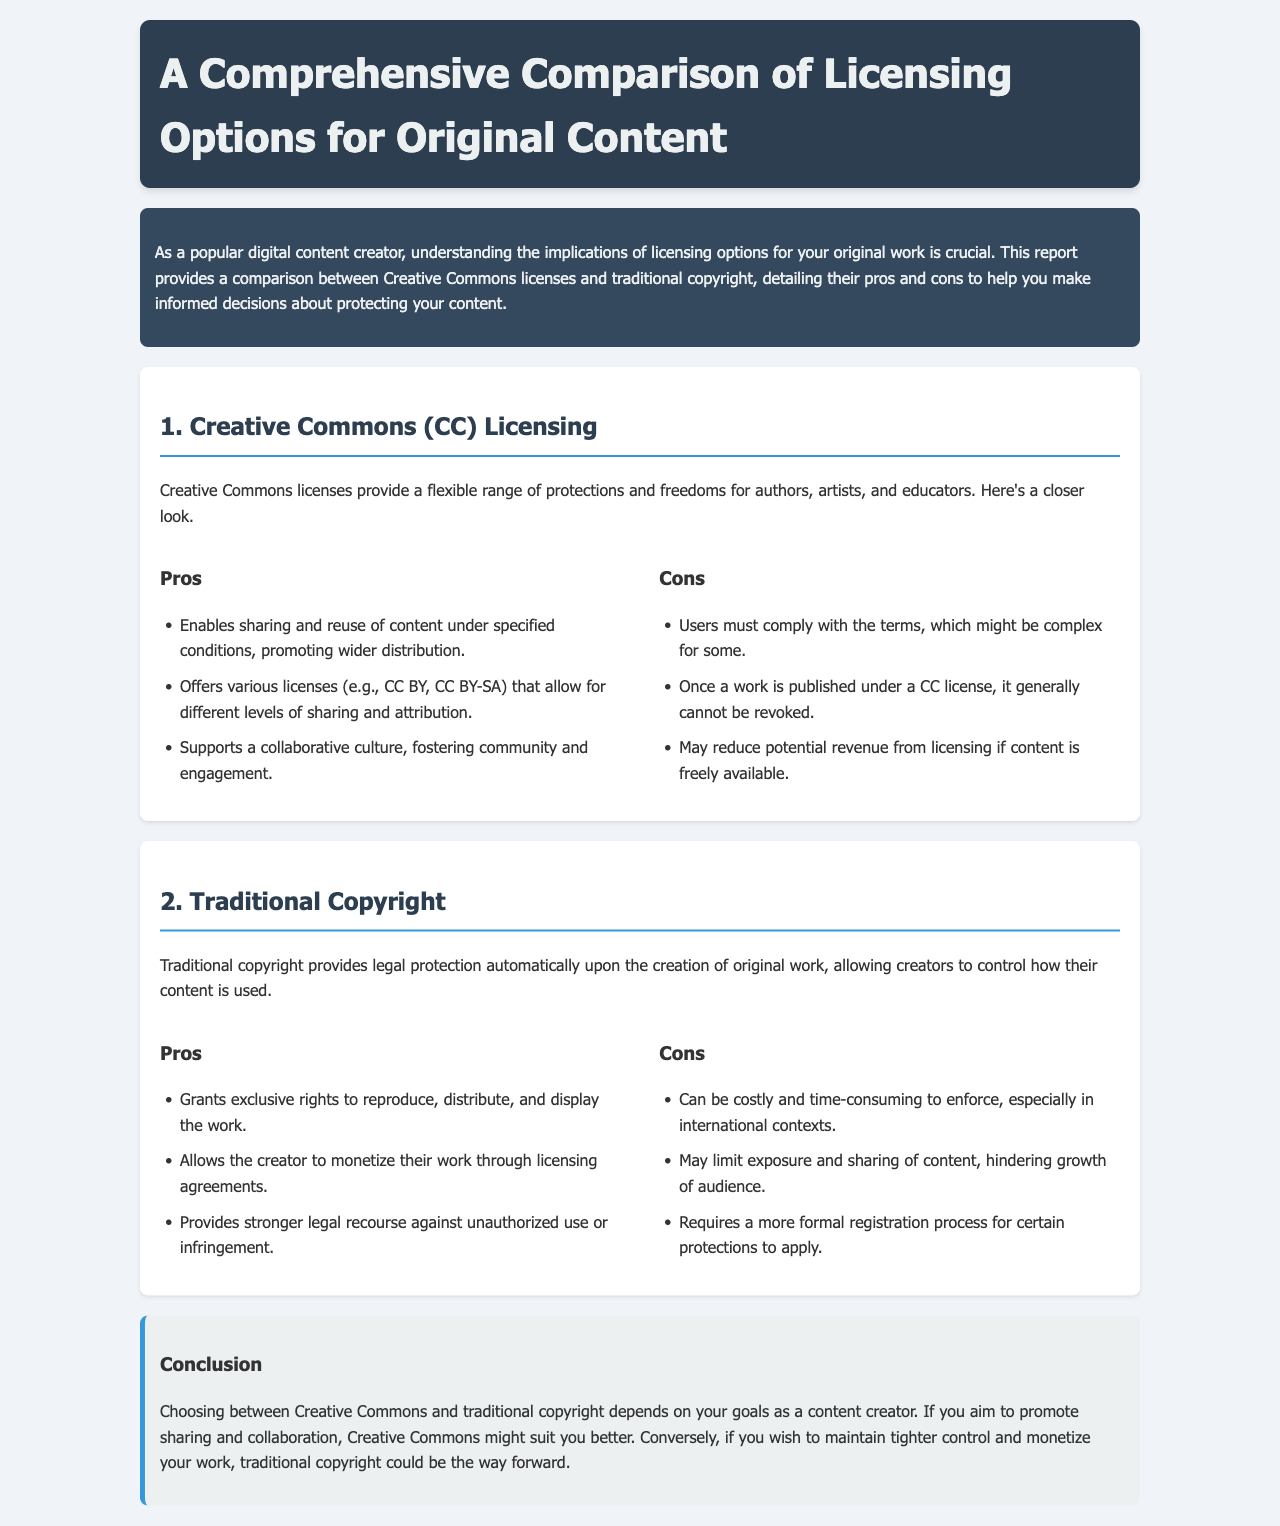What are the three pros of Creative Commons licenses? The three pros listed for Creative Commons licenses are: Enables sharing and reuse of content under specified conditions, Offers various licenses (e.g., CC BY, CC BY-SA), and Supports a collaborative culture.
Answer: Enables sharing and reuse of content under specified conditions, Offers various licenses (e.g., CC BY, CC BY-SA), Supports a collaborative culture What is one con of Creative Commons licensing? One con of Creative Commons licensing mentioned is that once a work is published under a CC license, it generally cannot be revoked.
Answer: Cannot be revoked What are the three pros of traditional copyright? The three pros listed for traditional copyright are: Grants exclusive rights to reproduce, distribute, and display the work, Allows the creator to monetize their work through licensing agreements, and Provides stronger legal recourse against unauthorized use or infringement.
Answer: Grants exclusive rights to reproduce, distribute, and display the work, Allows the creator to monetize their work through licensing agreements, Provides stronger legal recourse against unauthorized use or infringement What is one con of traditional copyright? One con of traditional copyright mentioned is that it can be costly and time-consuming to enforce, especially in international contexts.
Answer: Costly and time-consuming to enforce What should content creators consider when choosing between licensing options? Content creators should consider their goals, whether they aim to promote sharing and collaboration or wish to maintain tighter control and monetize their work.
Answer: Their goals 